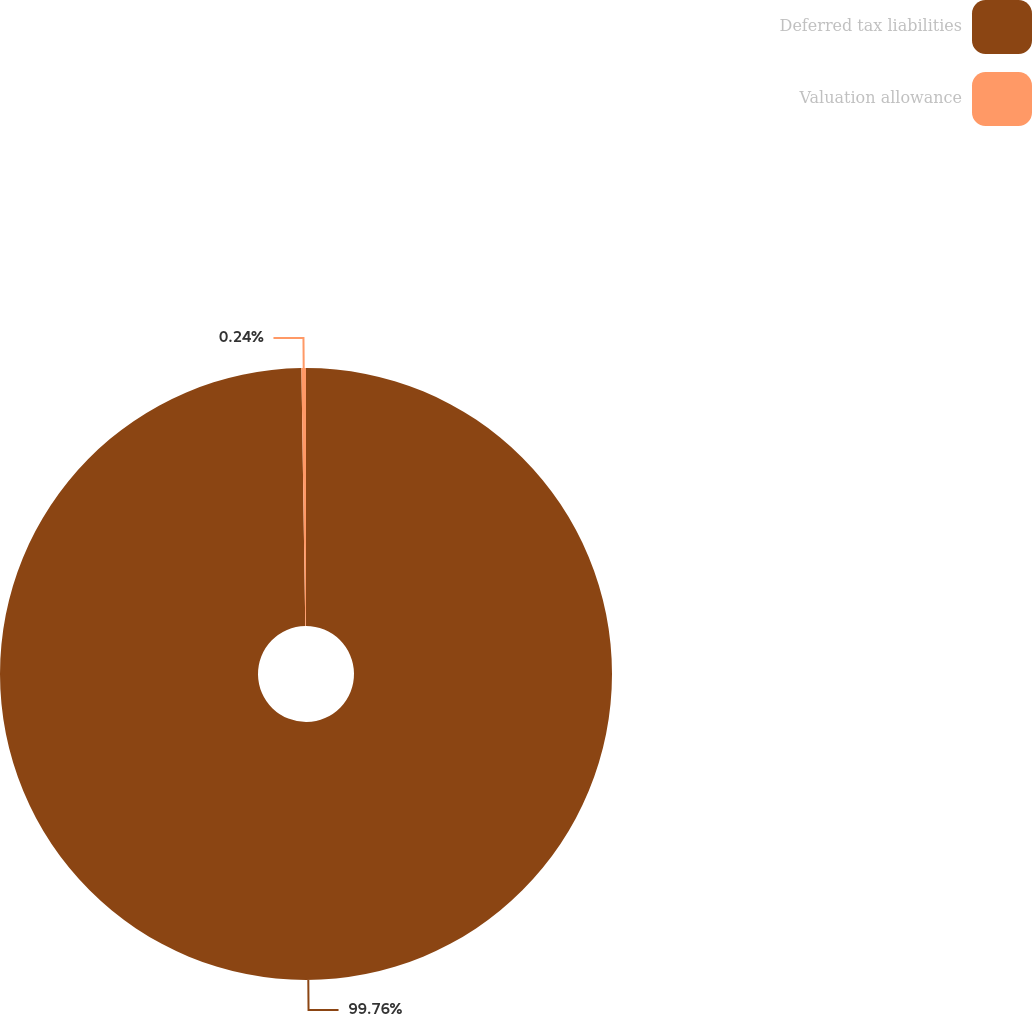Convert chart. <chart><loc_0><loc_0><loc_500><loc_500><pie_chart><fcel>Deferred tax liabilities<fcel>Valuation allowance<nl><fcel>99.76%<fcel>0.24%<nl></chart> 